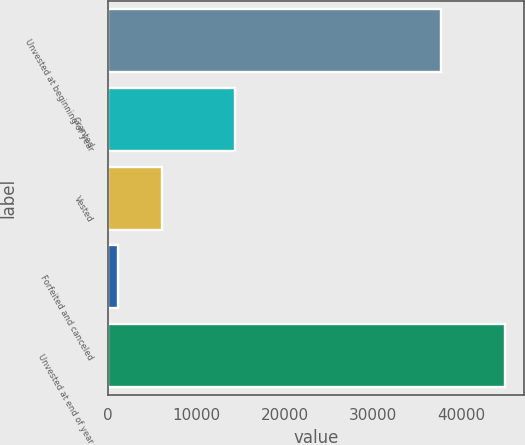Convert chart. <chart><loc_0><loc_0><loc_500><loc_500><bar_chart><fcel>Unvested at beginning of year<fcel>Granted<fcel>Vested<fcel>Forfeited and canceled<fcel>Unvested at end of year<nl><fcel>37727<fcel>14415<fcel>6126<fcel>1139<fcel>44877<nl></chart> 